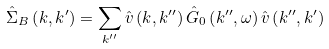<formula> <loc_0><loc_0><loc_500><loc_500>\hat { \Sigma } _ { B } \left ( { k } , { k } ^ { \prime } \right ) = \sum _ { k ^ { \prime \prime } } \hat { v } \left ( { k } , { k ^ { \prime \prime } } \right ) \hat { G } _ { 0 } \left ( { k ^ { \prime \prime } } , \omega \right ) \hat { v } \left ( { k ^ { \prime \prime } } , { k } ^ { \prime } \right )</formula> 